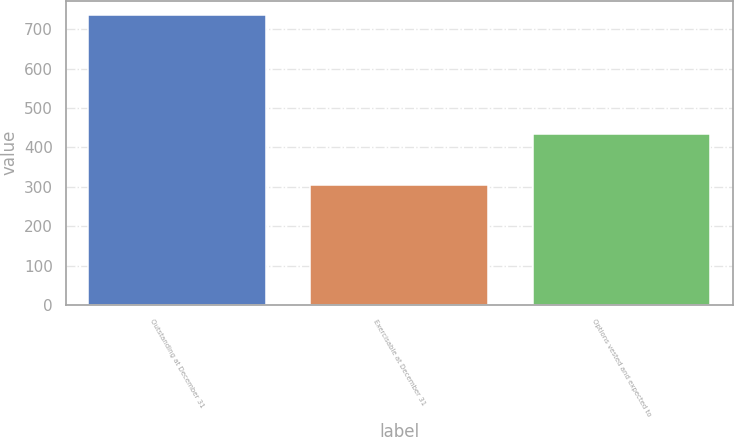Convert chart. <chart><loc_0><loc_0><loc_500><loc_500><bar_chart><fcel>Outstanding at December 31<fcel>Exercisable at December 31<fcel>Options vested and expected to<nl><fcel>736<fcel>305<fcel>433<nl></chart> 